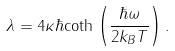<formula> <loc_0><loc_0><loc_500><loc_500>\lambda = 4 \kappa \hbar { \coth } \left ( \frac { \hbar { \omega } } { 2 k _ { B } T } \right ) .</formula> 